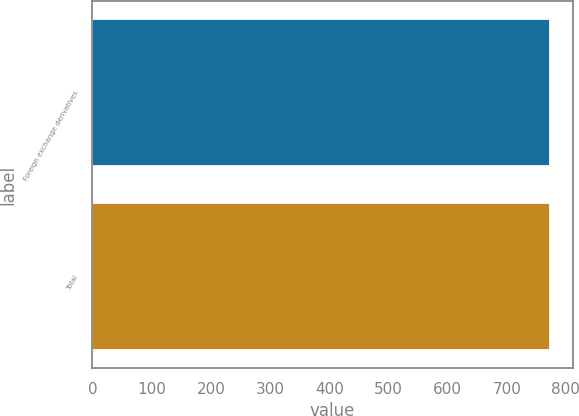Convert chart to OTSL. <chart><loc_0><loc_0><loc_500><loc_500><bar_chart><fcel>Foreign exchange derivatives<fcel>Total<nl><fcel>773<fcel>773.1<nl></chart> 